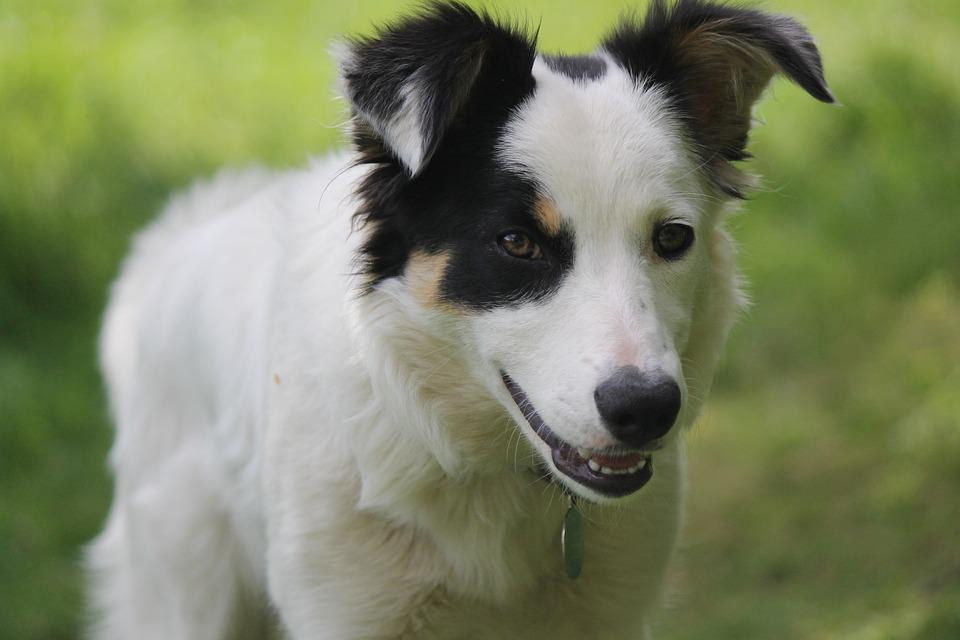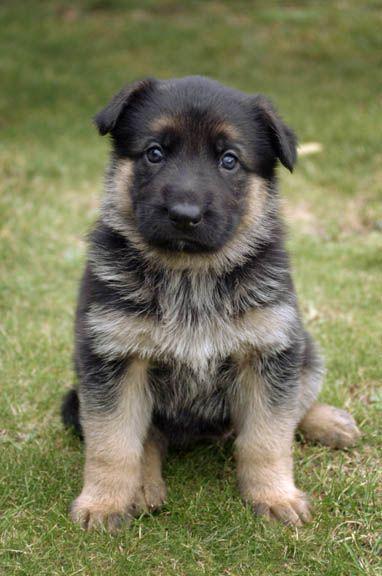The first image is the image on the left, the second image is the image on the right. Assess this claim about the two images: "The coat of the dog on the right is black and white only.". Correct or not? Answer yes or no. No. 